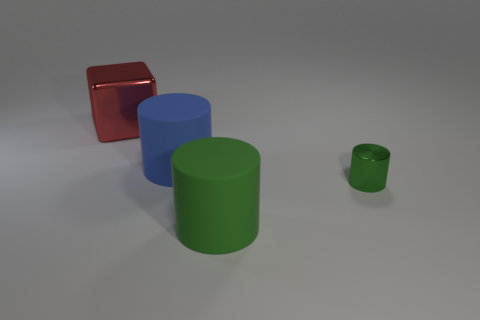Add 3 big yellow objects. How many objects exist? 7 Subtract all cubes. How many objects are left? 3 Add 1 large blue cylinders. How many large blue cylinders exist? 2 Subtract 0 gray cubes. How many objects are left? 4 Subtract all rubber objects. Subtract all tiny gray shiny balls. How many objects are left? 2 Add 3 big metal objects. How many big metal objects are left? 4 